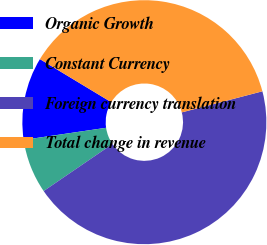<chart> <loc_0><loc_0><loc_500><loc_500><pie_chart><fcel>Organic Growth<fcel>Constant Currency<fcel>Foreign currency translation<fcel>Total change in revenue<nl><fcel>10.96%<fcel>7.23%<fcel>44.52%<fcel>37.28%<nl></chart> 